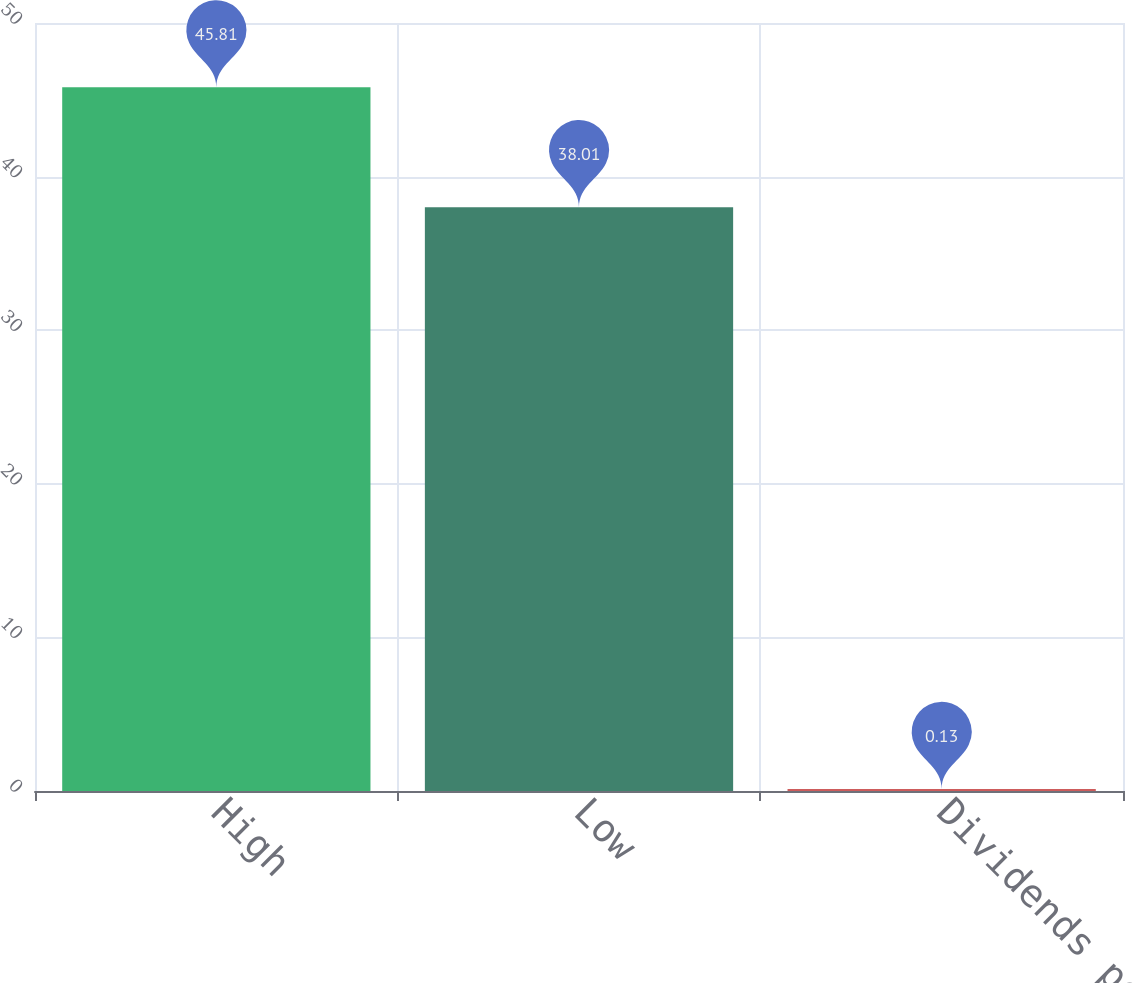<chart> <loc_0><loc_0><loc_500><loc_500><bar_chart><fcel>High<fcel>Low<fcel>Dividends per share<nl><fcel>45.81<fcel>38.01<fcel>0.13<nl></chart> 